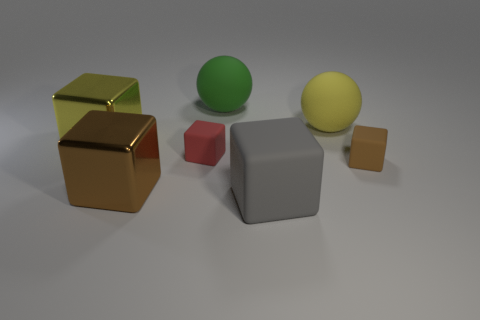Subtract all brown rubber blocks. How many blocks are left? 4 Add 2 tiny red metal balls. How many objects exist? 9 Subtract all blue cylinders. How many brown blocks are left? 2 Subtract all gray blocks. How many blocks are left? 4 Subtract all balls. How many objects are left? 5 Subtract all red balls. Subtract all blue blocks. How many balls are left? 2 Subtract all spheres. Subtract all big yellow rubber balls. How many objects are left? 4 Add 6 tiny red matte blocks. How many tiny red matte blocks are left? 7 Add 3 gray matte things. How many gray matte things exist? 4 Subtract 0 yellow cylinders. How many objects are left? 7 